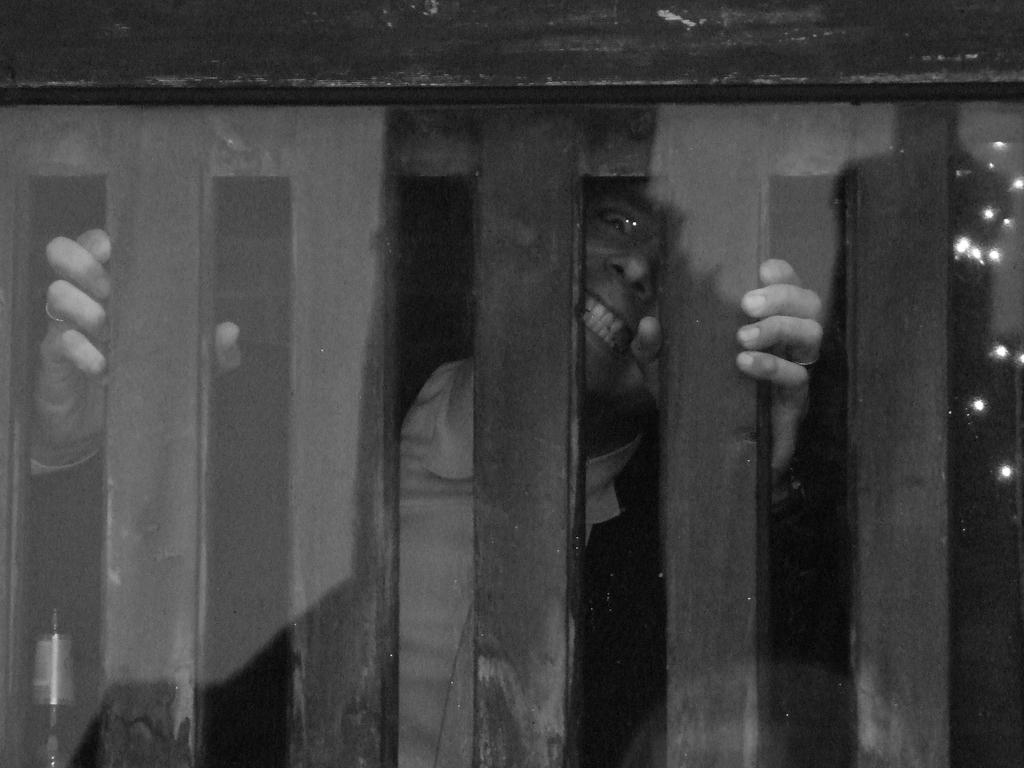Who is present in the image? There is a man in the image. What object can be seen in the man's hand? There is a glass in the image. What other beverage container is visible in the image? There is a bottle in the image. What can be seen providing illumination in the image? There are lights visible in the image. Is there an island visible in the image? No, there is no island present in the image. What type of drain is visible in the image? There is no drain present in the image. 